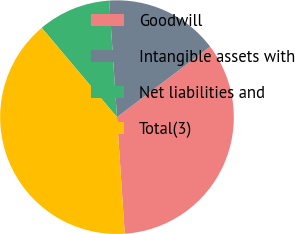Convert chart. <chart><loc_0><loc_0><loc_500><loc_500><pie_chart><fcel>Goodwill<fcel>Intangible assets with<fcel>Net liabilities and<fcel>Total(3)<nl><fcel>34.25%<fcel>15.75%<fcel>10.08%<fcel>39.92%<nl></chart> 